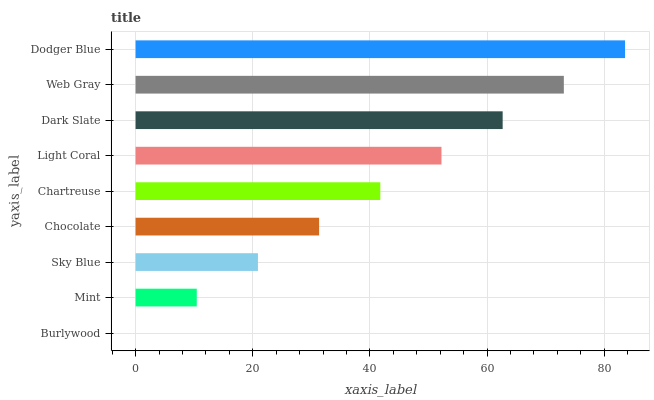Is Burlywood the minimum?
Answer yes or no. Yes. Is Dodger Blue the maximum?
Answer yes or no. Yes. Is Mint the minimum?
Answer yes or no. No. Is Mint the maximum?
Answer yes or no. No. Is Mint greater than Burlywood?
Answer yes or no. Yes. Is Burlywood less than Mint?
Answer yes or no. Yes. Is Burlywood greater than Mint?
Answer yes or no. No. Is Mint less than Burlywood?
Answer yes or no. No. Is Chartreuse the high median?
Answer yes or no. Yes. Is Chartreuse the low median?
Answer yes or no. Yes. Is Mint the high median?
Answer yes or no. No. Is Sky Blue the low median?
Answer yes or no. No. 